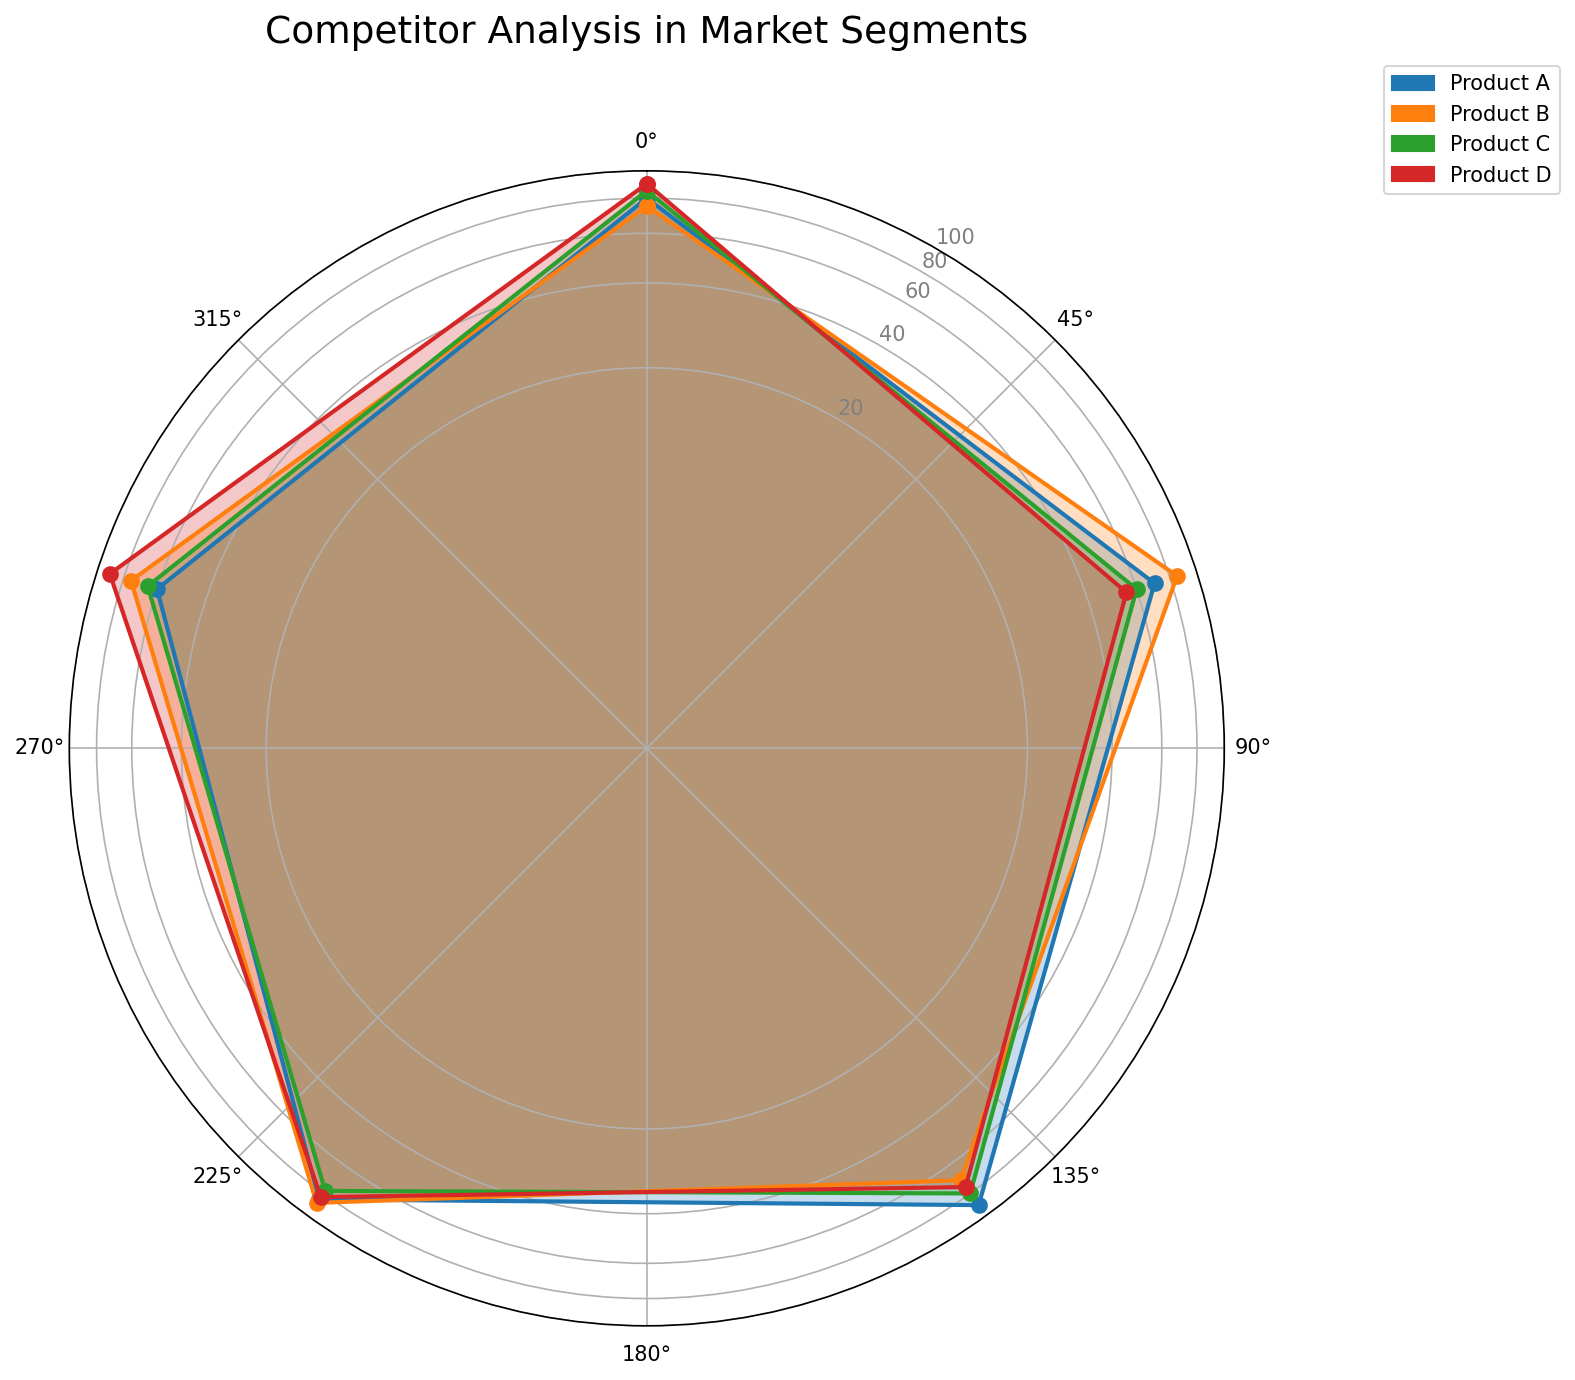What's the highest Ad Spend? To find the highest Ad Spend, look at the "Ad Spend" values for all products and identify the maximum value. For Product A it’s 60, B is 75, C is 65, and D is 90. The highest value is for Product D with 90.
Answer: Product D Which product has the lowest score for Price? Compare the "Price" scores for each product: Product A has 70, B has 85, C has 60, and D has 55. Product D has the lowest score of 55.
Answer: Product D Which product is the most balanced across all categories? Check the radar chart for the product whose values across categories are most even and closer to each other. Product B has values: 75, 85, 70, 88, 75—these are relatively balanced. The other products have more variance.
Answer: Product B Which products have Customer Reviews above 80? Look at the Customer Reviews for each product: Product A has 85, B has 88, C has 78, and D has 83. Products A, B, and D all have Customer Reviews above 80.
Answer: Products A, B, and D What's the average score for Product A? To calculate the average score for Product A, sum its scores and divide by the number of categories: (80 + 70 + 90 + 85 + 60) / 5 = 385 / 5 = 77.
Answer: 77 Which product shows the highest Popularity? For Popularity, look for the highest value among the products: Product A has 90, B has 70, C has 80, and D has 75. Product A has the highest Popularity of 90.
Answer: Product A Compare Product C and D: Which has a higher overall score? Sum their scores to compare: Product C: (85 + 60 + 80 + 78 + 65) = 368; Product D: (90 + 55 + 75 + 83 + 90) = 393. Product D has a higher overall score.
Answer: Product D How does the Ad Spend for Product A compare to Product B? Product A has an Ad Spend of 60, whereas Product B has 75. Product B's Ad Spend is higher than Product A's by 15.
Answer: Product B spends more What is the median value of Customer Reviews? Sort the Customer Reviews values: 78, 83, 85, 88. The median is the average of the two middle numbers (83+85)/2=84.
Answer: 84 